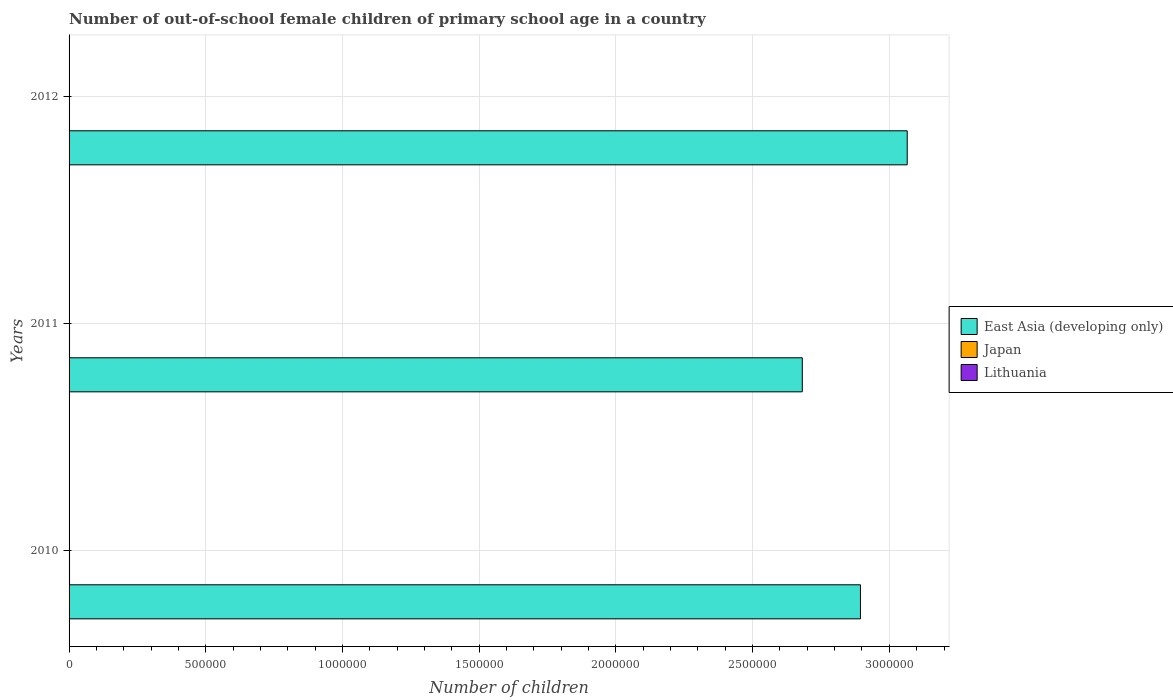Are the number of bars per tick equal to the number of legend labels?
Give a very brief answer. Yes. How many bars are there on the 3rd tick from the bottom?
Provide a succinct answer. 3. What is the number of out-of-school female children in East Asia (developing only) in 2010?
Provide a short and direct response. 2.89e+06. Across all years, what is the maximum number of out-of-school female children in Japan?
Give a very brief answer. 1693. Across all years, what is the minimum number of out-of-school female children in Lithuania?
Your answer should be compact. 855. In which year was the number of out-of-school female children in Japan maximum?
Provide a short and direct response. 2010. In which year was the number of out-of-school female children in Japan minimum?
Keep it short and to the point. 2012. What is the total number of out-of-school female children in Lithuania in the graph?
Ensure brevity in your answer.  2879. What is the difference between the number of out-of-school female children in Japan in 2010 and that in 2012?
Provide a short and direct response. 42. What is the difference between the number of out-of-school female children in Japan in 2010 and the number of out-of-school female children in East Asia (developing only) in 2011?
Provide a succinct answer. -2.68e+06. What is the average number of out-of-school female children in East Asia (developing only) per year?
Offer a terse response. 2.88e+06. In the year 2011, what is the difference between the number of out-of-school female children in Japan and number of out-of-school female children in Lithuania?
Give a very brief answer. 814. In how many years, is the number of out-of-school female children in Japan greater than 2800000 ?
Your answer should be compact. 0. What is the ratio of the number of out-of-school female children in Lithuania in 2010 to that in 2011?
Ensure brevity in your answer.  1. Is the number of out-of-school female children in Japan in 2011 less than that in 2012?
Offer a very short reply. No. What is the difference between the highest and the second highest number of out-of-school female children in East Asia (developing only)?
Your response must be concise. 1.71e+05. What is the difference between the highest and the lowest number of out-of-school female children in East Asia (developing only)?
Give a very brief answer. 3.84e+05. Is the sum of the number of out-of-school female children in Japan in 2011 and 2012 greater than the maximum number of out-of-school female children in East Asia (developing only) across all years?
Your answer should be compact. No. What does the 1st bar from the top in 2010 represents?
Your answer should be compact. Lithuania. What does the 2nd bar from the bottom in 2011 represents?
Offer a terse response. Japan. Is it the case that in every year, the sum of the number of out-of-school female children in East Asia (developing only) and number of out-of-school female children in Lithuania is greater than the number of out-of-school female children in Japan?
Offer a very short reply. Yes. Are all the bars in the graph horizontal?
Ensure brevity in your answer.  Yes. How many years are there in the graph?
Your response must be concise. 3. What is the difference between two consecutive major ticks on the X-axis?
Your answer should be compact. 5.00e+05. Where does the legend appear in the graph?
Your response must be concise. Center right. How many legend labels are there?
Offer a very short reply. 3. What is the title of the graph?
Provide a succinct answer. Number of out-of-school female children of primary school age in a country. Does "St. Kitts and Nevis" appear as one of the legend labels in the graph?
Ensure brevity in your answer.  No. What is the label or title of the X-axis?
Your answer should be compact. Number of children. What is the Number of children of East Asia (developing only) in 2010?
Your answer should be compact. 2.89e+06. What is the Number of children in Japan in 2010?
Provide a succinct answer. 1693. What is the Number of children in Lithuania in 2010?
Keep it short and to the point. 857. What is the Number of children of East Asia (developing only) in 2011?
Keep it short and to the point. 2.68e+06. What is the Number of children of Japan in 2011?
Your answer should be very brief. 1669. What is the Number of children of Lithuania in 2011?
Your answer should be compact. 855. What is the Number of children of East Asia (developing only) in 2012?
Keep it short and to the point. 3.07e+06. What is the Number of children in Japan in 2012?
Keep it short and to the point. 1651. What is the Number of children of Lithuania in 2012?
Offer a very short reply. 1167. Across all years, what is the maximum Number of children in East Asia (developing only)?
Offer a terse response. 3.07e+06. Across all years, what is the maximum Number of children of Japan?
Your answer should be very brief. 1693. Across all years, what is the maximum Number of children in Lithuania?
Your answer should be compact. 1167. Across all years, what is the minimum Number of children of East Asia (developing only)?
Your response must be concise. 2.68e+06. Across all years, what is the minimum Number of children of Japan?
Provide a succinct answer. 1651. Across all years, what is the minimum Number of children in Lithuania?
Your answer should be compact. 855. What is the total Number of children of East Asia (developing only) in the graph?
Your response must be concise. 8.64e+06. What is the total Number of children of Japan in the graph?
Give a very brief answer. 5013. What is the total Number of children in Lithuania in the graph?
Provide a short and direct response. 2879. What is the difference between the Number of children in East Asia (developing only) in 2010 and that in 2011?
Offer a very short reply. 2.13e+05. What is the difference between the Number of children of East Asia (developing only) in 2010 and that in 2012?
Your answer should be very brief. -1.71e+05. What is the difference between the Number of children in Japan in 2010 and that in 2012?
Your response must be concise. 42. What is the difference between the Number of children in Lithuania in 2010 and that in 2012?
Provide a short and direct response. -310. What is the difference between the Number of children in East Asia (developing only) in 2011 and that in 2012?
Ensure brevity in your answer.  -3.84e+05. What is the difference between the Number of children of Japan in 2011 and that in 2012?
Offer a terse response. 18. What is the difference between the Number of children of Lithuania in 2011 and that in 2012?
Ensure brevity in your answer.  -312. What is the difference between the Number of children in East Asia (developing only) in 2010 and the Number of children in Japan in 2011?
Offer a terse response. 2.89e+06. What is the difference between the Number of children in East Asia (developing only) in 2010 and the Number of children in Lithuania in 2011?
Your answer should be very brief. 2.89e+06. What is the difference between the Number of children of Japan in 2010 and the Number of children of Lithuania in 2011?
Offer a very short reply. 838. What is the difference between the Number of children in East Asia (developing only) in 2010 and the Number of children in Japan in 2012?
Give a very brief answer. 2.89e+06. What is the difference between the Number of children in East Asia (developing only) in 2010 and the Number of children in Lithuania in 2012?
Provide a short and direct response. 2.89e+06. What is the difference between the Number of children of Japan in 2010 and the Number of children of Lithuania in 2012?
Your answer should be very brief. 526. What is the difference between the Number of children in East Asia (developing only) in 2011 and the Number of children in Japan in 2012?
Give a very brief answer. 2.68e+06. What is the difference between the Number of children in East Asia (developing only) in 2011 and the Number of children in Lithuania in 2012?
Your response must be concise. 2.68e+06. What is the difference between the Number of children of Japan in 2011 and the Number of children of Lithuania in 2012?
Ensure brevity in your answer.  502. What is the average Number of children of East Asia (developing only) per year?
Provide a short and direct response. 2.88e+06. What is the average Number of children in Japan per year?
Offer a terse response. 1671. What is the average Number of children of Lithuania per year?
Ensure brevity in your answer.  959.67. In the year 2010, what is the difference between the Number of children in East Asia (developing only) and Number of children in Japan?
Provide a succinct answer. 2.89e+06. In the year 2010, what is the difference between the Number of children in East Asia (developing only) and Number of children in Lithuania?
Give a very brief answer. 2.89e+06. In the year 2010, what is the difference between the Number of children in Japan and Number of children in Lithuania?
Your response must be concise. 836. In the year 2011, what is the difference between the Number of children of East Asia (developing only) and Number of children of Japan?
Make the answer very short. 2.68e+06. In the year 2011, what is the difference between the Number of children in East Asia (developing only) and Number of children in Lithuania?
Make the answer very short. 2.68e+06. In the year 2011, what is the difference between the Number of children of Japan and Number of children of Lithuania?
Provide a succinct answer. 814. In the year 2012, what is the difference between the Number of children of East Asia (developing only) and Number of children of Japan?
Make the answer very short. 3.06e+06. In the year 2012, what is the difference between the Number of children of East Asia (developing only) and Number of children of Lithuania?
Offer a terse response. 3.06e+06. In the year 2012, what is the difference between the Number of children in Japan and Number of children in Lithuania?
Provide a succinct answer. 484. What is the ratio of the Number of children of East Asia (developing only) in 2010 to that in 2011?
Your answer should be compact. 1.08. What is the ratio of the Number of children in Japan in 2010 to that in 2011?
Offer a very short reply. 1.01. What is the ratio of the Number of children of East Asia (developing only) in 2010 to that in 2012?
Keep it short and to the point. 0.94. What is the ratio of the Number of children of Japan in 2010 to that in 2012?
Offer a terse response. 1.03. What is the ratio of the Number of children of Lithuania in 2010 to that in 2012?
Your answer should be compact. 0.73. What is the ratio of the Number of children in East Asia (developing only) in 2011 to that in 2012?
Offer a terse response. 0.87. What is the ratio of the Number of children of Japan in 2011 to that in 2012?
Provide a short and direct response. 1.01. What is the ratio of the Number of children of Lithuania in 2011 to that in 2012?
Your answer should be very brief. 0.73. What is the difference between the highest and the second highest Number of children of East Asia (developing only)?
Keep it short and to the point. 1.71e+05. What is the difference between the highest and the second highest Number of children of Lithuania?
Make the answer very short. 310. What is the difference between the highest and the lowest Number of children in East Asia (developing only)?
Provide a succinct answer. 3.84e+05. What is the difference between the highest and the lowest Number of children of Lithuania?
Keep it short and to the point. 312. 